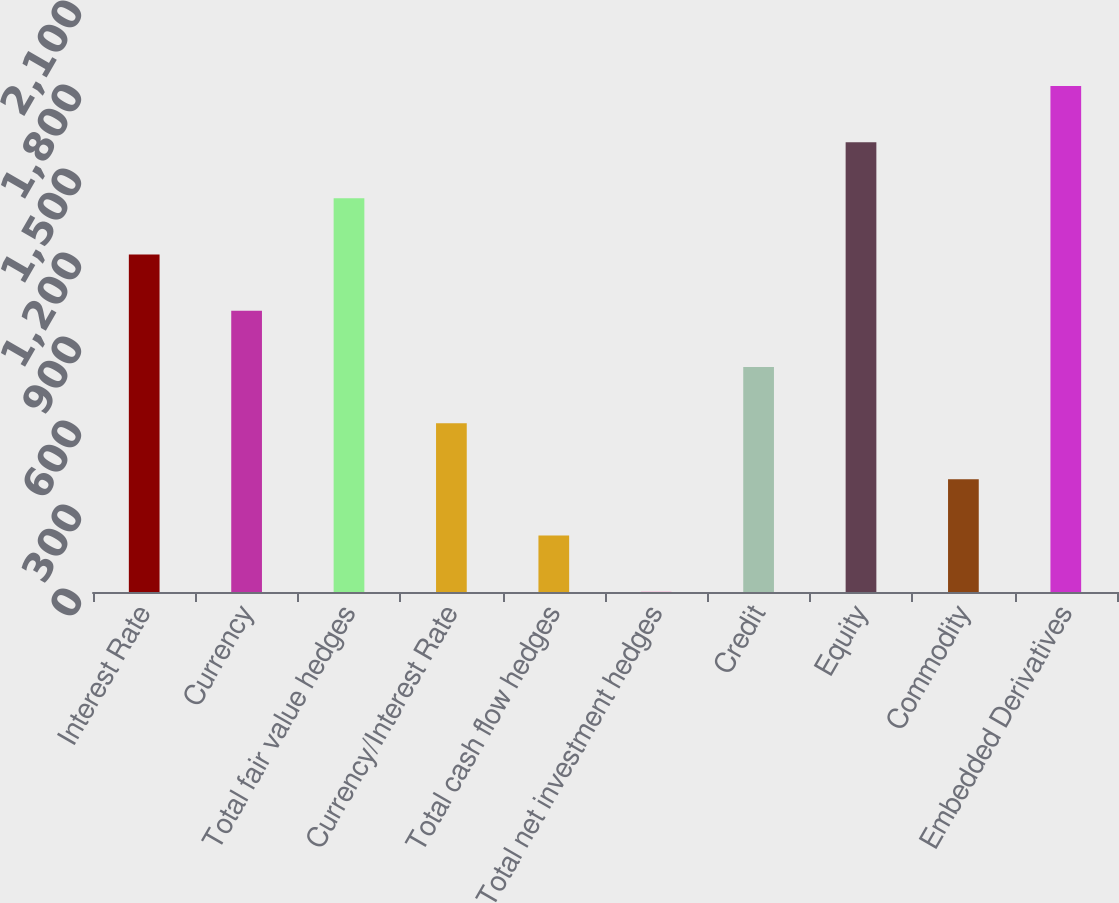<chart> <loc_0><loc_0><loc_500><loc_500><bar_chart><fcel>Interest Rate<fcel>Currency<fcel>Total fair value hedges<fcel>Currency/Interest Rate<fcel>Total cash flow hedges<fcel>Total net investment hedges<fcel>Credit<fcel>Equity<fcel>Commodity<fcel>Embedded Derivatives<nl><fcel>1205.13<fcel>1004.41<fcel>1405.85<fcel>602.97<fcel>201.53<fcel>0.81<fcel>803.69<fcel>1606.57<fcel>402.25<fcel>1807.29<nl></chart> 